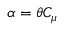Convert formula to latex. <formula><loc_0><loc_0><loc_500><loc_500>\alpha = \theta C _ { \mu }</formula> 